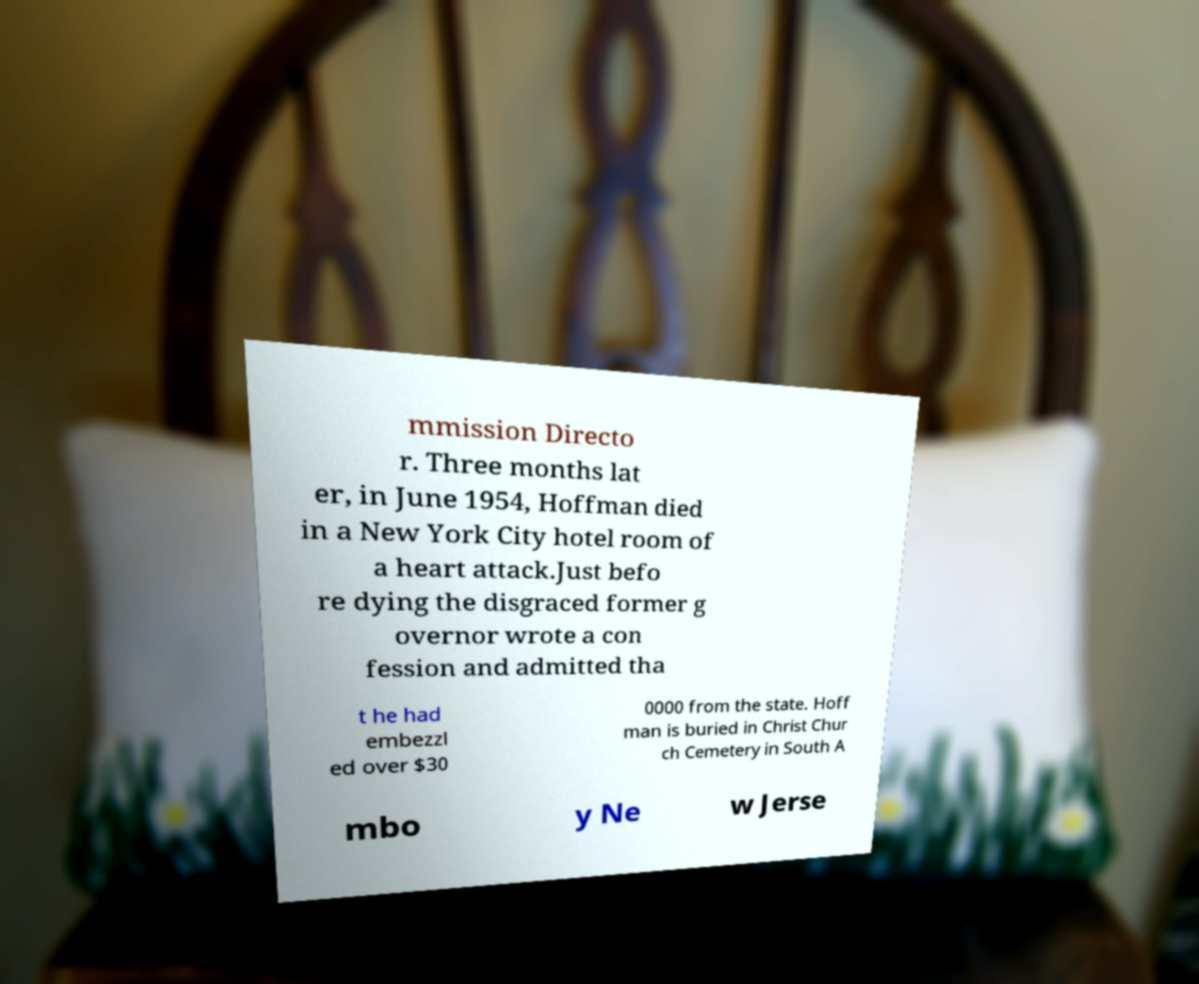Please read and relay the text visible in this image. What does it say? mmission Directo r. Three months lat er, in June 1954, Hoffman died in a New York City hotel room of a heart attack.Just befo re dying the disgraced former g overnor wrote a con fession and admitted tha t he had embezzl ed over $30 0000 from the state. Hoff man is buried in Christ Chur ch Cemetery in South A mbo y Ne w Jerse 